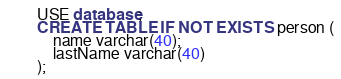<code> <loc_0><loc_0><loc_500><loc_500><_SQL_>USE database;
CREATE TABLE IF NOT EXISTS person (
	name varchar(40);
	lastName varchar(40)
);</code> 